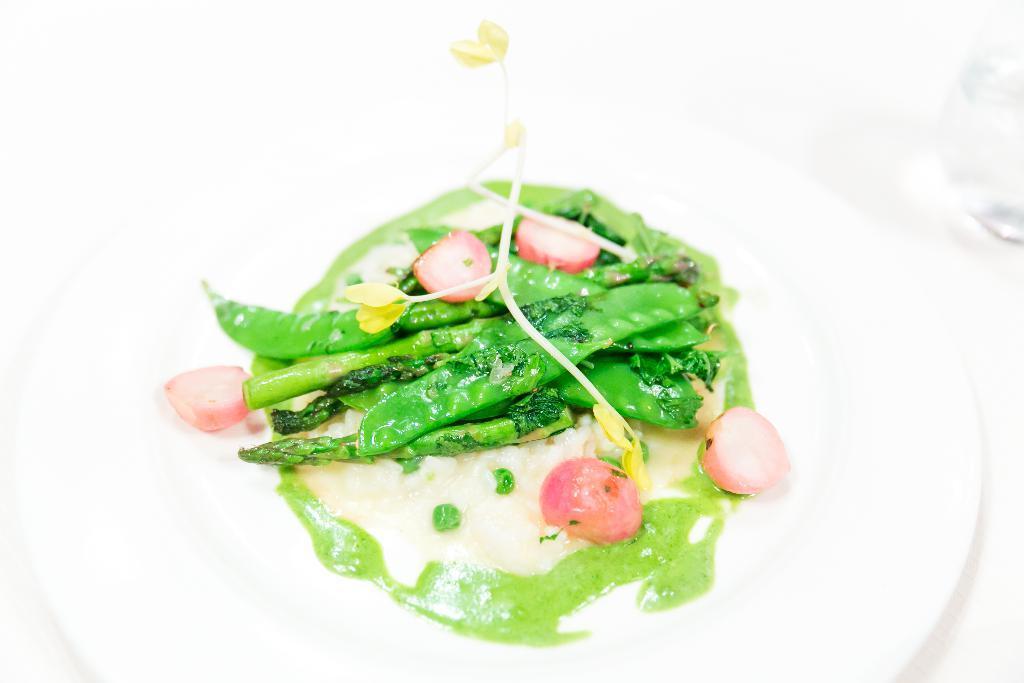Could you give a brief overview of what you see in this image? In this picture I can see food in the plate and I can see a glass on the right side and I can see white color background. 